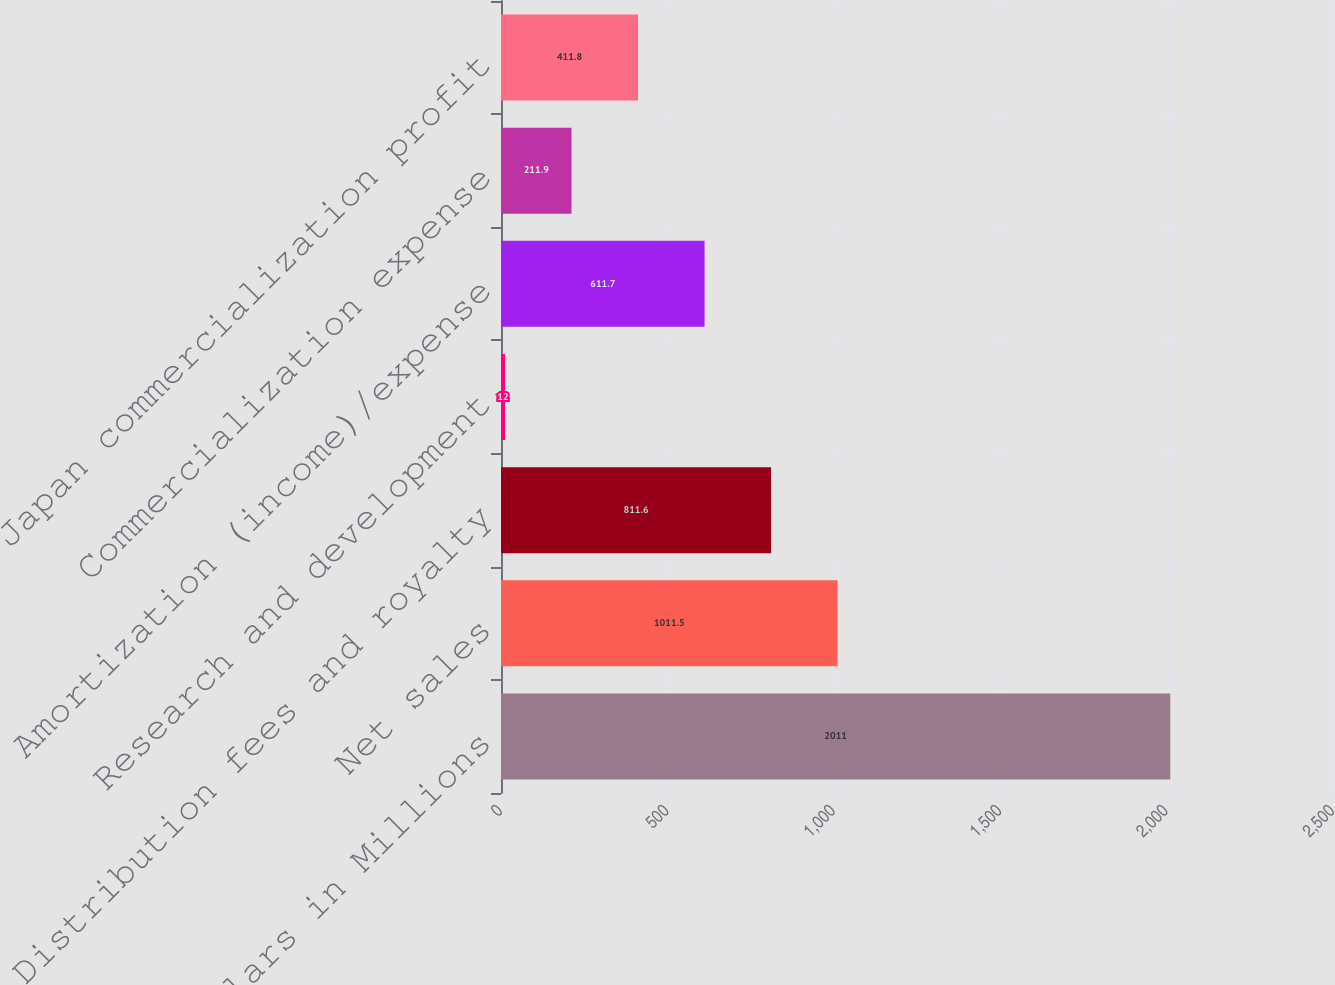Convert chart. <chart><loc_0><loc_0><loc_500><loc_500><bar_chart><fcel>Dollars in Millions<fcel>Net sales<fcel>Distribution fees and royalty<fcel>Research and development<fcel>Amortization (income)/expense<fcel>Commercialization expense<fcel>Japan commercialization profit<nl><fcel>2011<fcel>1011.5<fcel>811.6<fcel>12<fcel>611.7<fcel>211.9<fcel>411.8<nl></chart> 